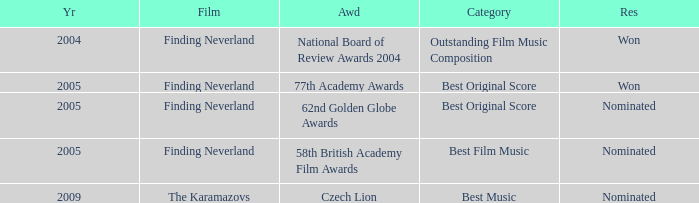How many years were there for the 62nd golden globe awards? 2005.0. 